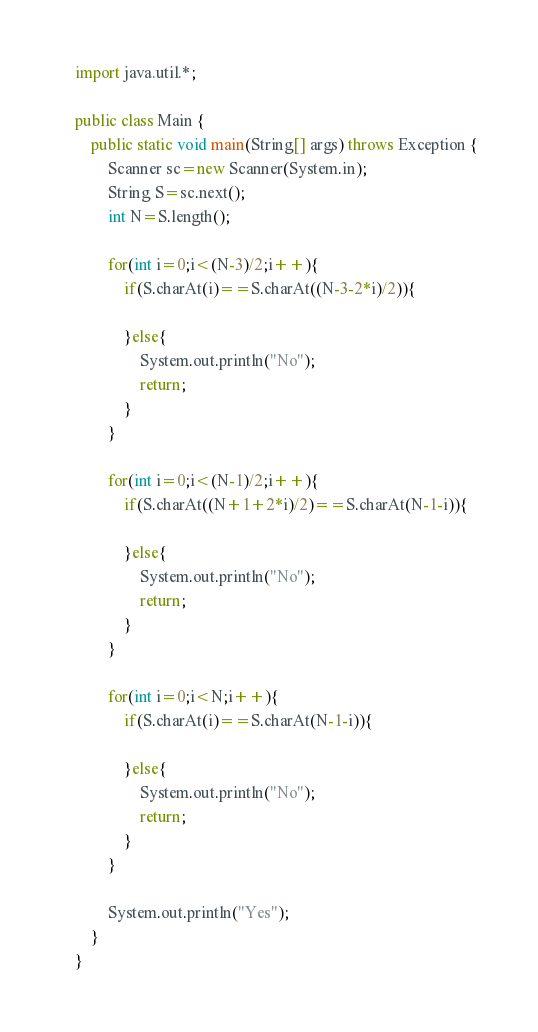<code> <loc_0><loc_0><loc_500><loc_500><_Java_>import java.util.*;

public class Main {
    public static void main(String[] args) throws Exception {
        Scanner sc=new Scanner(System.in);
        String S=sc.next();
        int N=S.length();
        
        for(int i=0;i<(N-3)/2;i++){
            if(S.charAt(i)==S.charAt((N-3-2*i)/2)){
                
            }else{
                System.out.println("No");
                return;
            }
        }
        
        for(int i=0;i<(N-1)/2;i++){
            if(S.charAt((N+1+2*i)/2)==S.charAt(N-1-i)){
                
            }else{
                System.out.println("No");
                return;
            }
        }
        
        for(int i=0;i<N;i++){
            if(S.charAt(i)==S.charAt(N-1-i)){
                
            }else{
                System.out.println("No");
                return;
            }
        }
        
        System.out.println("Yes");
    }
}
</code> 